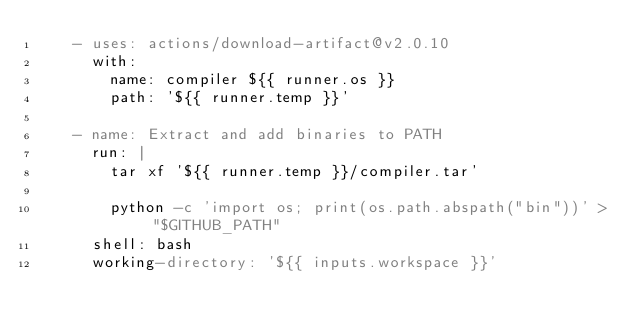<code> <loc_0><loc_0><loc_500><loc_500><_YAML_>    - uses: actions/download-artifact@v2.0.10
      with:
        name: compiler ${{ runner.os }}
        path: '${{ runner.temp }}'

    - name: Extract and add binaries to PATH
      run: |
        tar xf '${{ runner.temp }}/compiler.tar'

        python -c 'import os; print(os.path.abspath("bin"))' > "$GITHUB_PATH"
      shell: bash
      working-directory: '${{ inputs.workspace }}'
</code> 